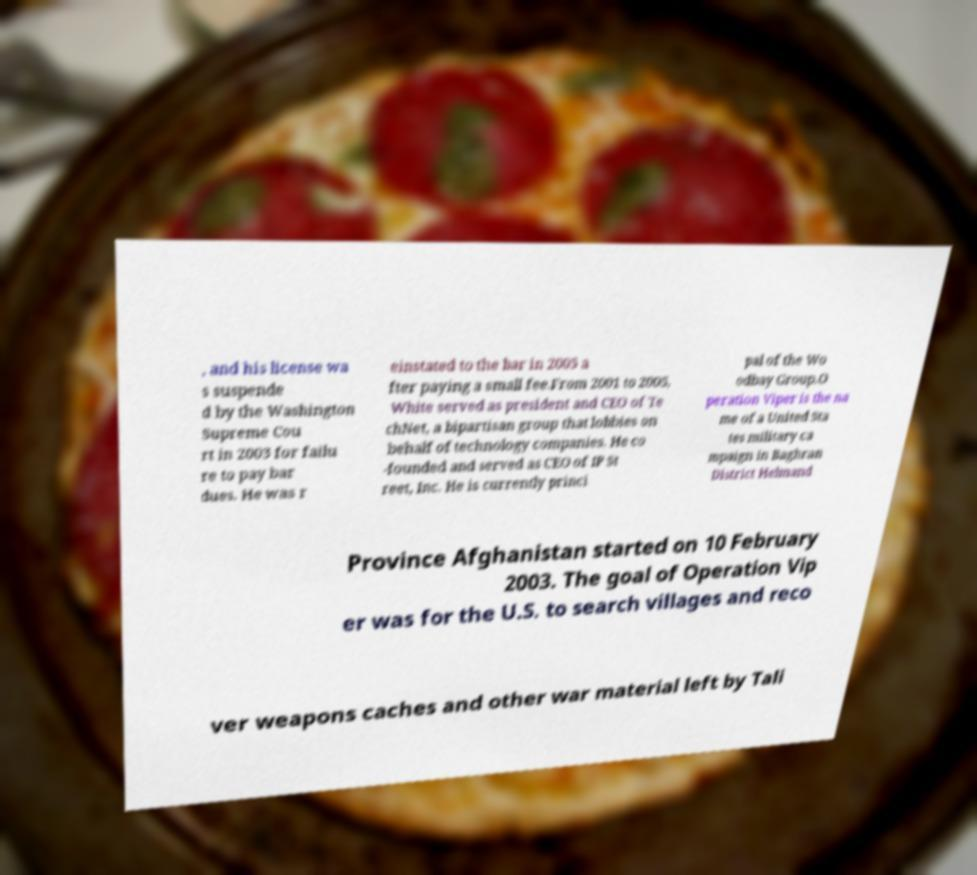Could you extract and type out the text from this image? , and his license wa s suspende d by the Washington Supreme Cou rt in 2003 for failu re to pay bar dues. He was r einstated to the bar in 2005 a fter paying a small fee.From 2001 to 2005, White served as president and CEO of Te chNet, a bipartisan group that lobbies on behalf of technology companies. He co -founded and served as CEO of IP St reet, Inc. He is currently princi pal of the Wo odbay Group.O peration Viper is the na me of a United Sta tes military ca mpaign in Baghran District Helmand Province Afghanistan started on 10 February 2003. The goal of Operation Vip er was for the U.S. to search villages and reco ver weapons caches and other war material left by Tali 